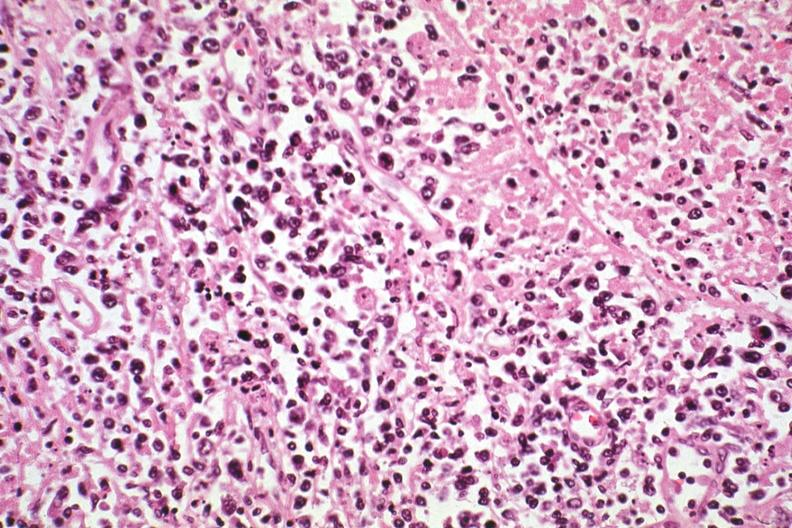what see other slides in file?
Answer the question using a single word or phrase. Hodgkins 